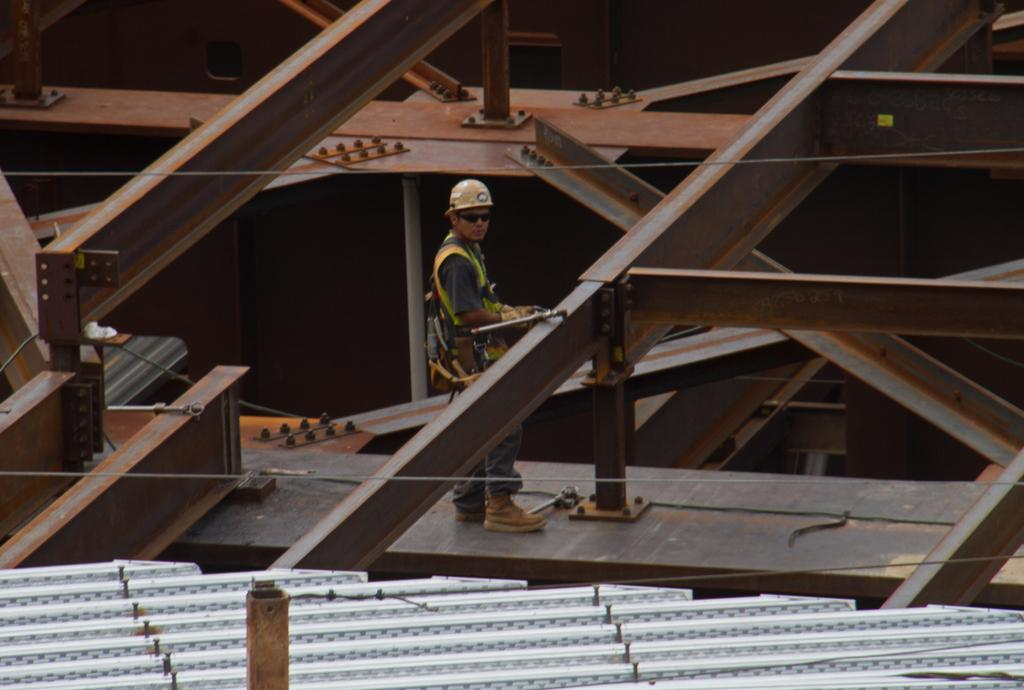What is the person in the image doing? The person is standing on an iron rod in the image. What structure can be seen in the background of the image? There is a shed in the image. What type of plastic objects can be seen in the image? There is no plastic object present in the image. Is there a birthday celebration happening in the image? There is no indication of a birthday celebration in the image. 